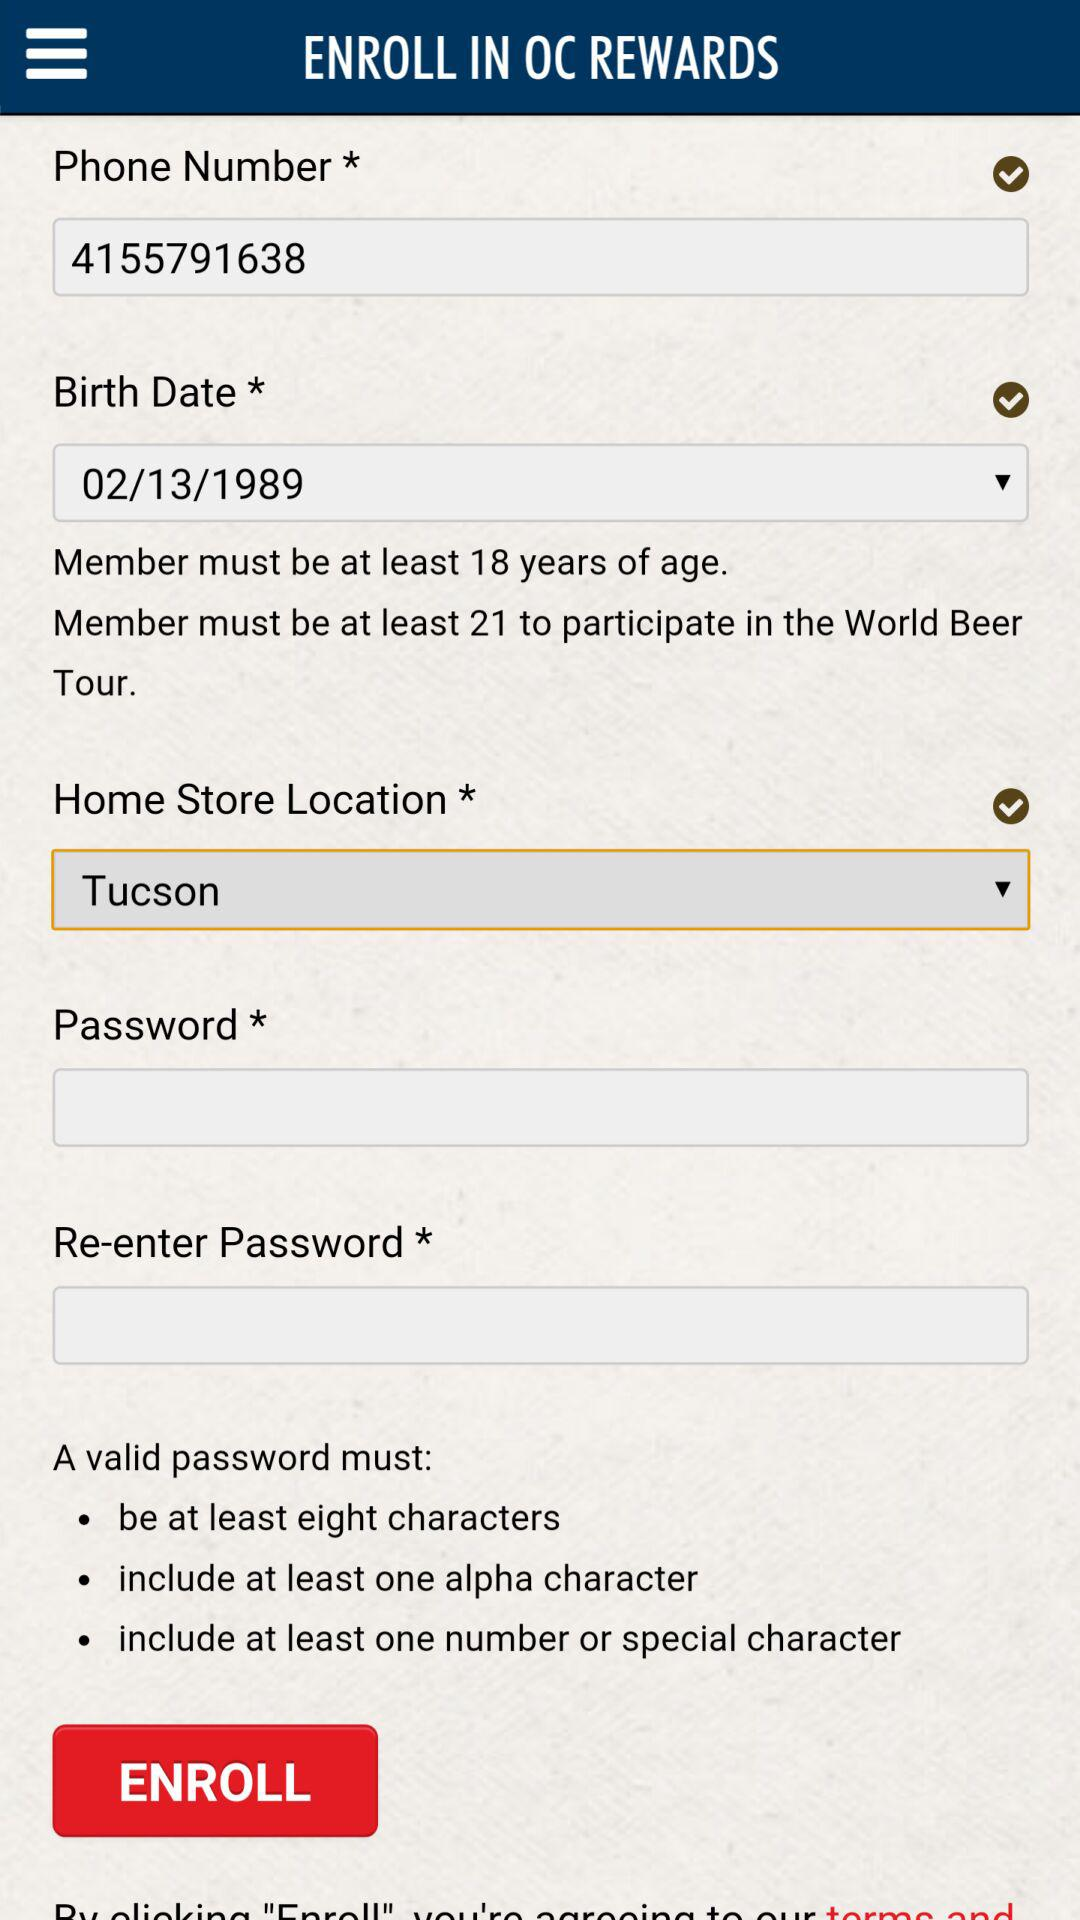What is the entered phone number? The entered phone number is 4155791638. 